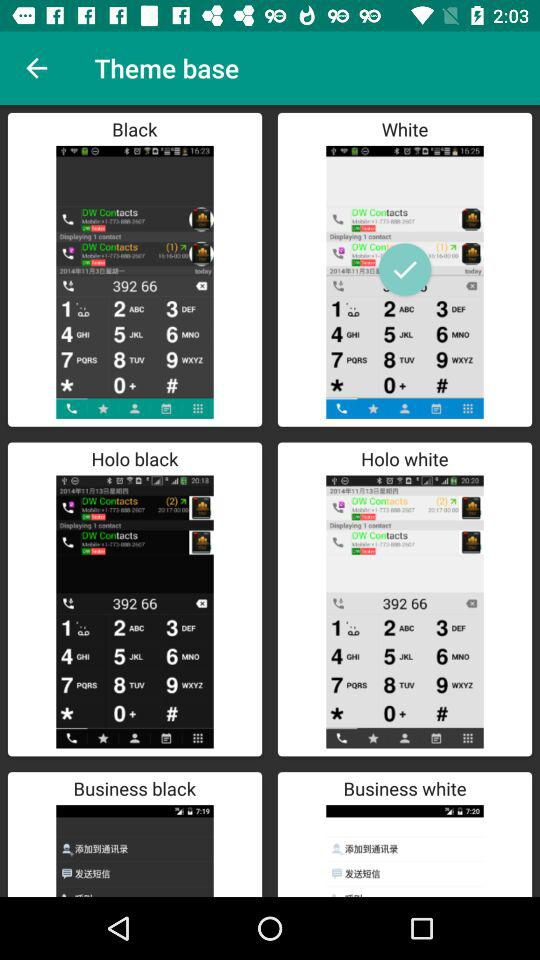Which theme base is selected? The selected theme base is "White". 